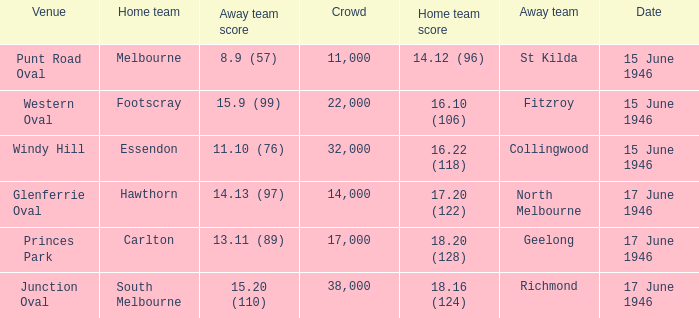On what date was a game played at Windy Hill? 15 June 1946. 